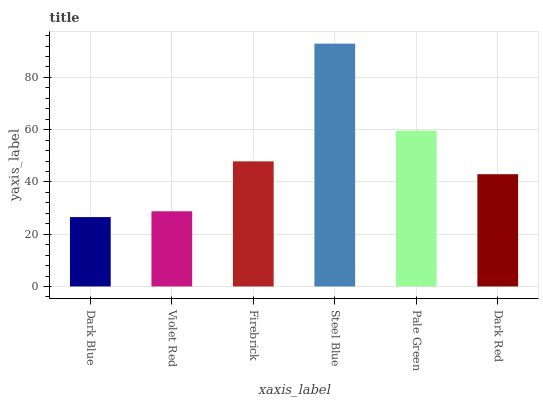Is Violet Red the minimum?
Answer yes or no. No. Is Violet Red the maximum?
Answer yes or no. No. Is Violet Red greater than Dark Blue?
Answer yes or no. Yes. Is Dark Blue less than Violet Red?
Answer yes or no. Yes. Is Dark Blue greater than Violet Red?
Answer yes or no. No. Is Violet Red less than Dark Blue?
Answer yes or no. No. Is Firebrick the high median?
Answer yes or no. Yes. Is Dark Red the low median?
Answer yes or no. Yes. Is Dark Blue the high median?
Answer yes or no. No. Is Dark Blue the low median?
Answer yes or no. No. 